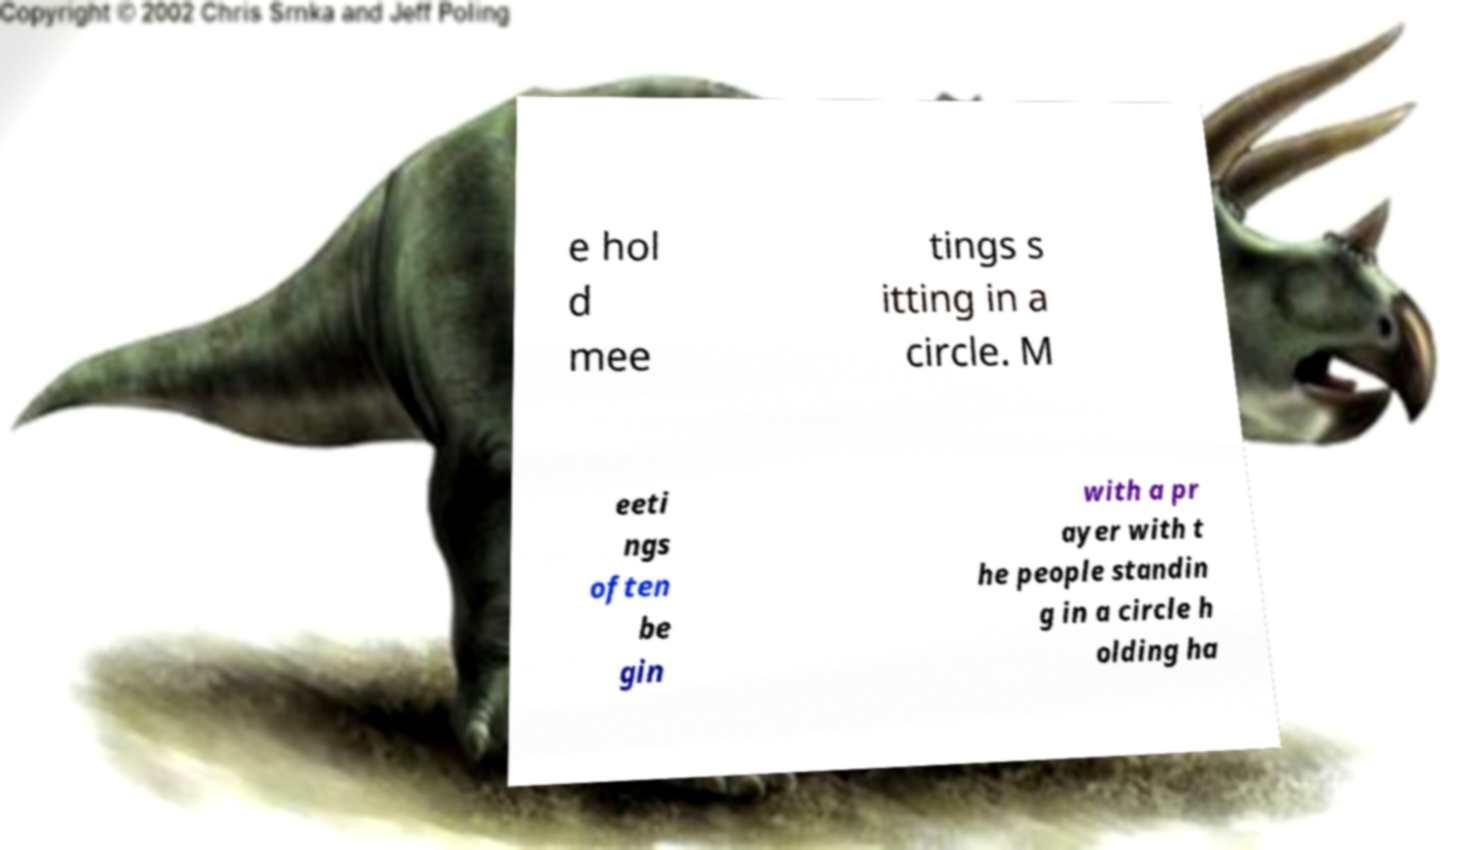Could you extract and type out the text from this image? e hol d mee tings s itting in a circle. M eeti ngs often be gin with a pr ayer with t he people standin g in a circle h olding ha 